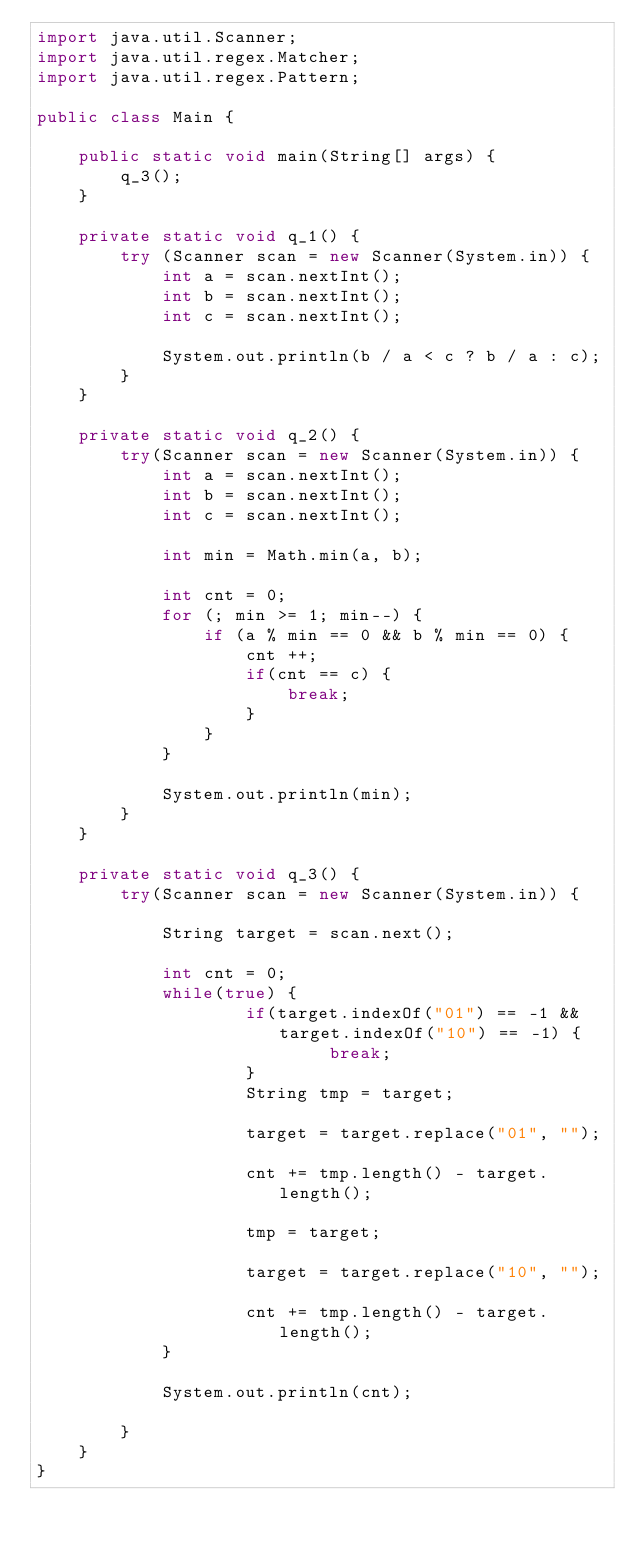Convert code to text. <code><loc_0><loc_0><loc_500><loc_500><_Java_>import java.util.Scanner;
import java.util.regex.Matcher;
import java.util.regex.Pattern;
 
public class Main {
 
    public static void main(String[] args) {
        q_3();
    }
 
    private static void q_1() {
        try (Scanner scan = new Scanner(System.in)) {
            int a = scan.nextInt();
            int b = scan.nextInt();
            int c = scan.nextInt();
 
            System.out.println(b / a < c ? b / a : c);
        }
    }
 
    private static void q_2() {
        try(Scanner scan = new Scanner(System.in)) {
            int a = scan.nextInt();
            int b = scan.nextInt();
            int c = scan.nextInt();
 
            int min = Math.min(a, b);
 
            int cnt = 0;
            for (; min >= 1; min--) {
                if (a % min == 0 && b % min == 0) {
                    cnt ++;
                    if(cnt == c) {
                        break;
                    }
                }
            }
 
            System.out.println(min);
        }
    }
 
    private static void q_3() {
        try(Scanner scan = new Scanner(System.in)) {
 
            String target = scan.next();
 
            int cnt = 0;
            while(true) {
                    if(target.indexOf("01") == -1 && target.indexOf("10") == -1) {
                            break;
                    }
                    String tmp = target;
 
                    target = target.replace("01", "");
 
                    cnt += tmp.length() - target.length();
 
                    tmp = target;
 
                    target = target.replace("10", "");
 
                    cnt += tmp.length() - target.length();
            }
 
            System.out.println(cnt);
 
        }
    }
}</code> 